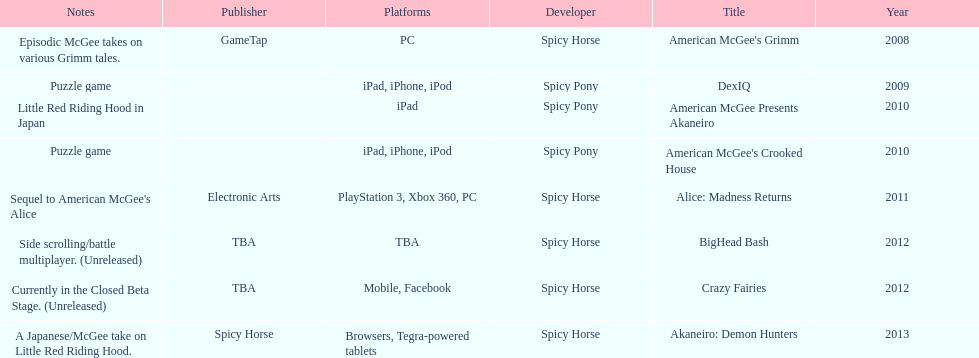According to the table, what is the last title that spicy horse produced? Akaneiro: Demon Hunters. 